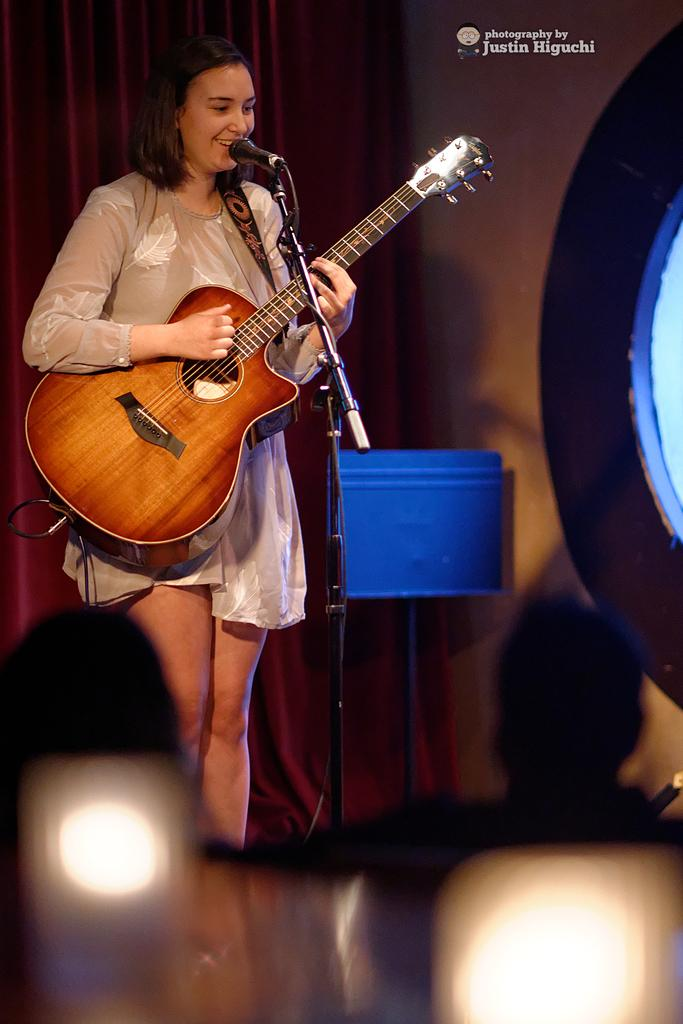What is the gender of the person in the image? The person in the image is a lady. What is the lady person wearing in the image? The lady person is wearing a white dress. What activity is the lady person engaged in? The lady person is playing a guitar. What object is in front of the lady person? There is a microphone in front of the lady person. What type of ice is being used to learn division in the image? There is no ice or learning activity present in the image; it features a lady person playing a guitar with a microphone in front of her. 